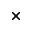Convert formula to latex. <formula><loc_0><loc_0><loc_500><loc_500>_ { \times }</formula> 